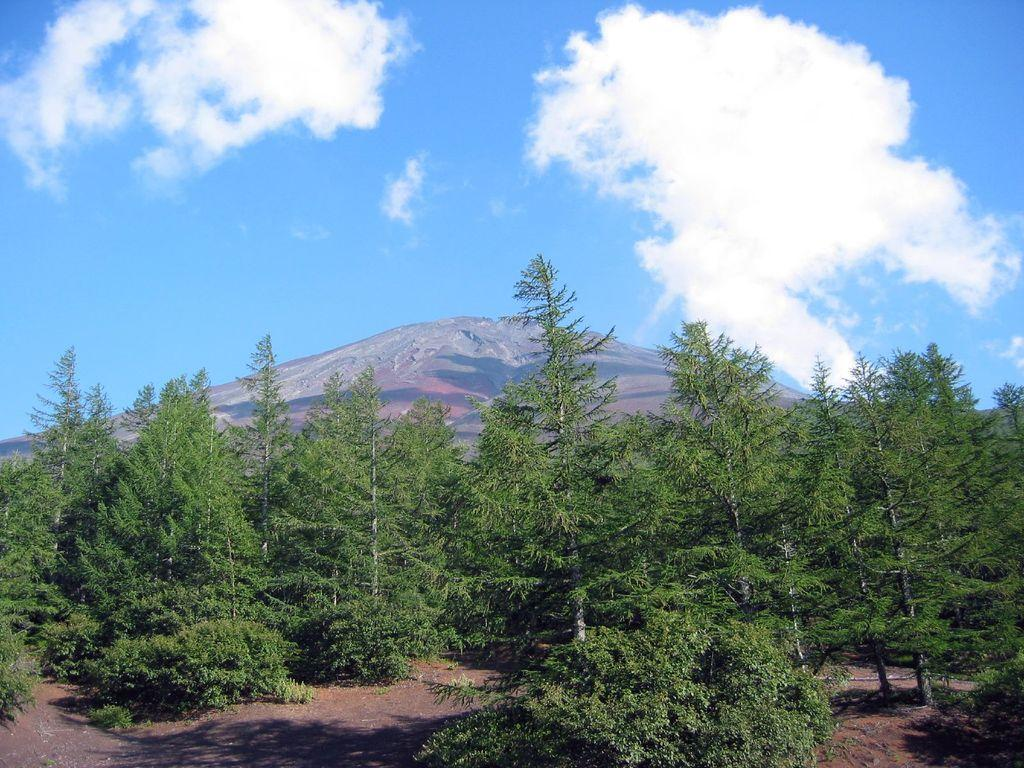What type of vegetation is present at the bottom of the image? There are trees on the ground at the bottom of the image. What geographical feature can be seen in the background of the image? There is a mountain in the background of the image. What is visible in the sky in the background of the image? There are clouds in the sky in the background of the image. Can you see a monkey climbing the trees in the image? There is no monkey present in the image; only trees are visible at the bottom. Is there a tiger hiding behind the mountain in the image? There is no tiger present in the image; only a mountain and clouds are visible in the background. 